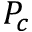Convert formula to latex. <formula><loc_0><loc_0><loc_500><loc_500>P _ { c }</formula> 